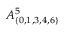Convert formula to latex. <formula><loc_0><loc_0><loc_500><loc_500>A _ { \{ 0 , 1 , 3 , 4 , 6 \} } ^ { 5 }</formula> 